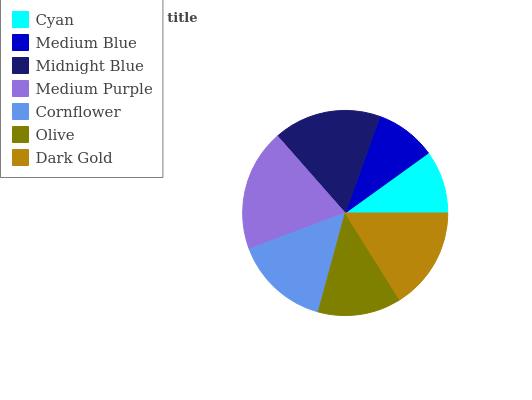Is Medium Blue the minimum?
Answer yes or no. Yes. Is Medium Purple the maximum?
Answer yes or no. Yes. Is Midnight Blue the minimum?
Answer yes or no. No. Is Midnight Blue the maximum?
Answer yes or no. No. Is Midnight Blue greater than Medium Blue?
Answer yes or no. Yes. Is Medium Blue less than Midnight Blue?
Answer yes or no. Yes. Is Medium Blue greater than Midnight Blue?
Answer yes or no. No. Is Midnight Blue less than Medium Blue?
Answer yes or no. No. Is Cornflower the high median?
Answer yes or no. Yes. Is Cornflower the low median?
Answer yes or no. Yes. Is Olive the high median?
Answer yes or no. No. Is Midnight Blue the low median?
Answer yes or no. No. 